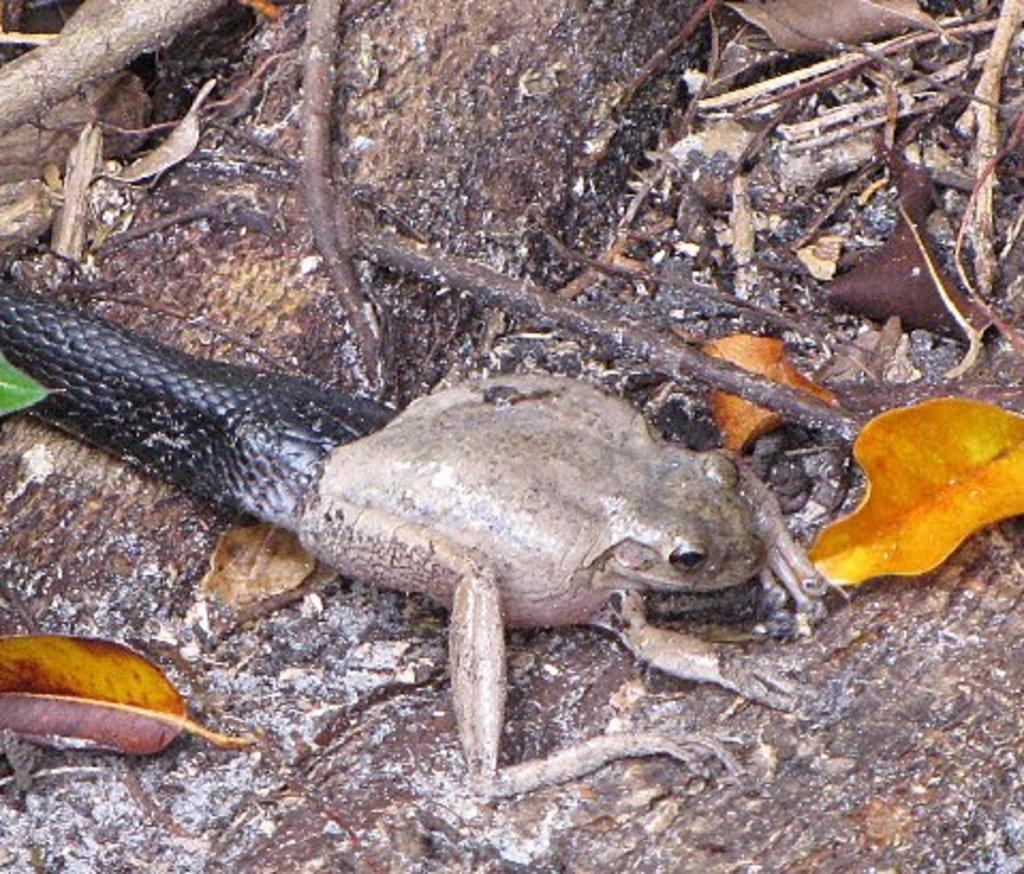What type of animals can be seen in the image? There is a frog and a snake in the image. What type of natural elements are present in the image? Dry leaves and twigs are present in the image. What is the surface mentioned in the image? The wooden surface is mentioned in the context of the image. Where can the library be found in the image? There is no library present in the image. Is there a note attached to the shelf in the image? There is no shelf or note present in the image. 